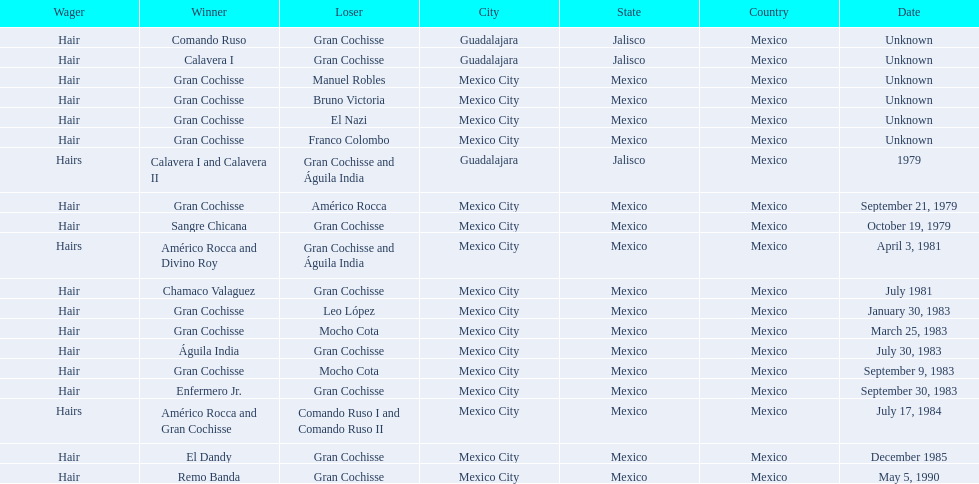When did bruno victoria lose his first game? Unknown. 